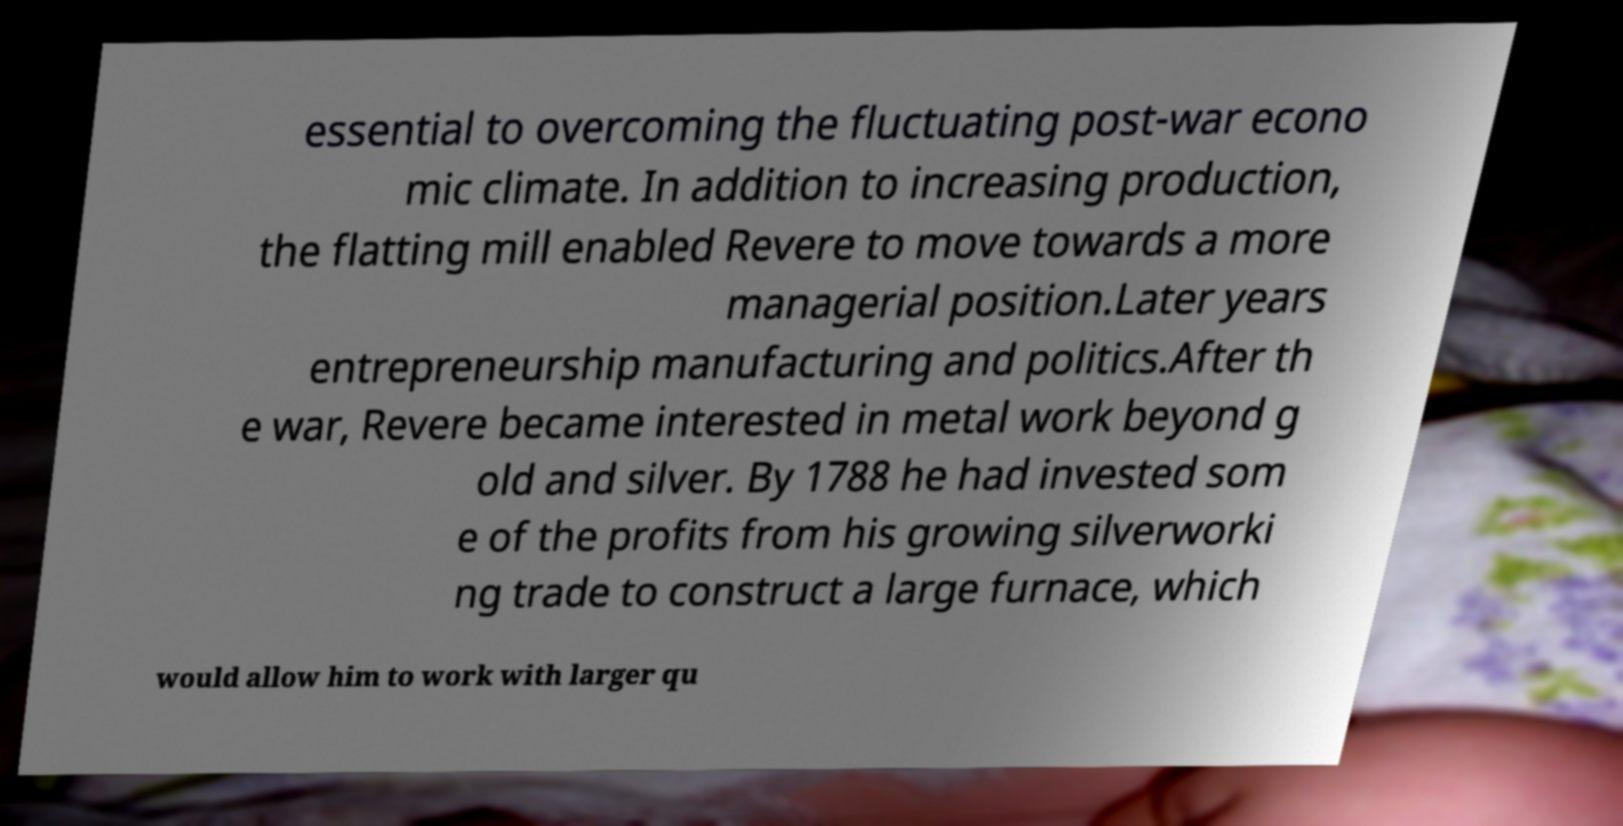Please read and relay the text visible in this image. What does it say? essential to overcoming the fluctuating post-war econo mic climate. In addition to increasing production, the flatting mill enabled Revere to move towards a more managerial position.Later years entrepreneurship manufacturing and politics.After th e war, Revere became interested in metal work beyond g old and silver. By 1788 he had invested som e of the profits from his growing silverworki ng trade to construct a large furnace, which would allow him to work with larger qu 